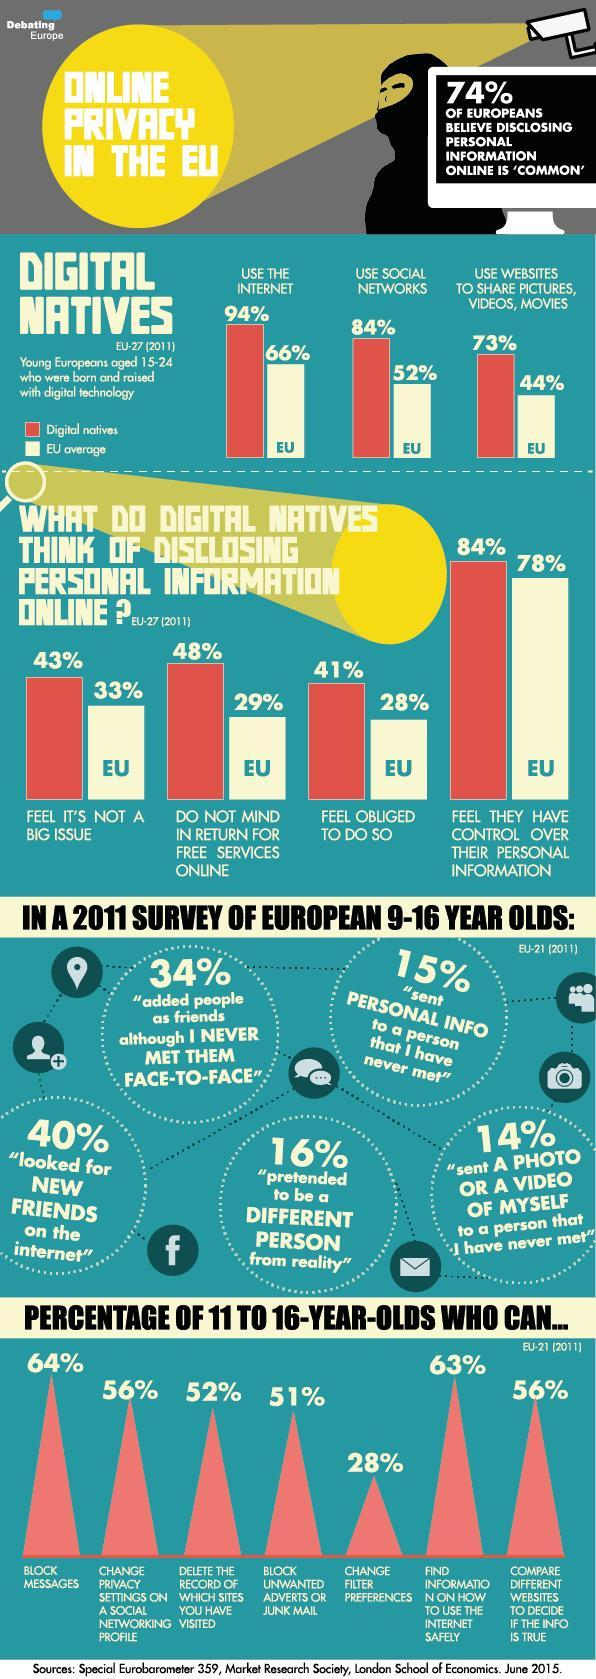How many of the 11-16 year olds can block unwanted ads or junk mail?
Answer the question with a short phrase. 51% What percent of people in EU do not mind disclosing personal information for free services online? 29% What percent of 11-16 year olds can block messages? 64% What percent of people in EU use websites to share pictures, videos, etc? 44% How many of the digital natives use the internet? 94% What percent of digital natives use social networks? 84% What percent of 11-16 year olds can change filter preferences? 28% 